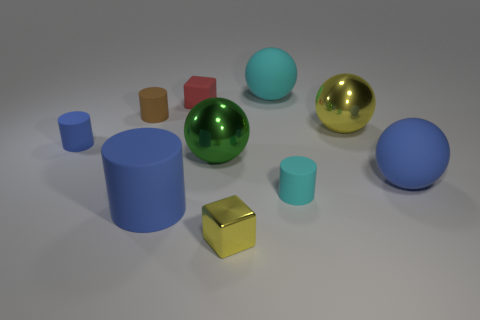There is a rubber sphere that is in front of the tiny rubber cube; is it the same color as the big matte cylinder?
Ensure brevity in your answer.  Yes. Are the small blue thing in front of the big yellow sphere and the cube on the right side of the green sphere made of the same material?
Your answer should be very brief. No. There is a rubber thing in front of the cyan rubber cylinder; does it have the same size as the red thing?
Provide a succinct answer. No. What shape is the metal thing that is the same color as the small shiny block?
Ensure brevity in your answer.  Sphere. Is the color of the large cylinder the same as the matte cube?
Ensure brevity in your answer.  No. What size is the sphere that is the same color as the tiny shiny cube?
Your response must be concise. Large. What material is the cyan object behind the large yellow shiny ball?
Provide a short and direct response. Rubber. Is the number of cyan spheres that are in front of the yellow ball the same as the number of gray spheres?
Offer a very short reply. Yes. Is there anything else that has the same size as the yellow sphere?
Give a very brief answer. Yes. What material is the blue cylinder in front of the big green object to the left of the cyan rubber ball?
Give a very brief answer. Rubber. 